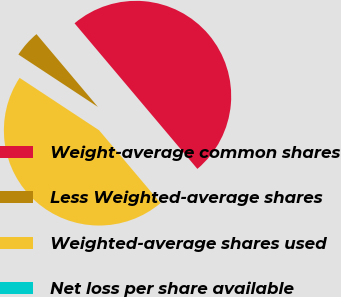<chart> <loc_0><loc_0><loc_500><loc_500><pie_chart><fcel>Weight-average common shares<fcel>Less Weighted-average shares<fcel>Weighted-average shares used<fcel>Net loss per share available<nl><fcel>50.0%<fcel>4.57%<fcel>45.43%<fcel>0.0%<nl></chart> 